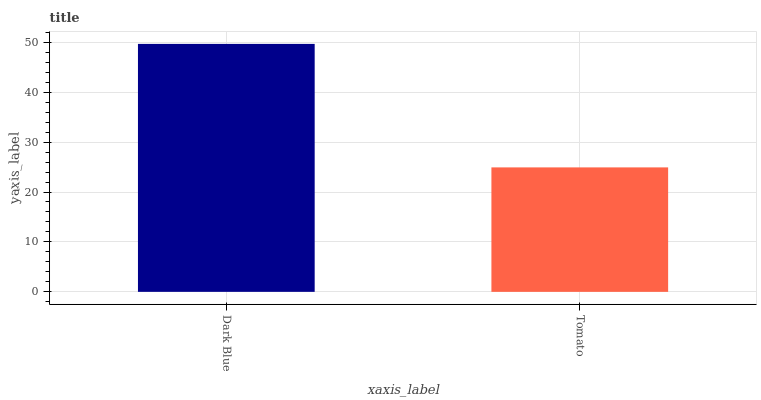Is Tomato the maximum?
Answer yes or no. No. Is Dark Blue greater than Tomato?
Answer yes or no. Yes. Is Tomato less than Dark Blue?
Answer yes or no. Yes. Is Tomato greater than Dark Blue?
Answer yes or no. No. Is Dark Blue less than Tomato?
Answer yes or no. No. Is Dark Blue the high median?
Answer yes or no. Yes. Is Tomato the low median?
Answer yes or no. Yes. Is Tomato the high median?
Answer yes or no. No. Is Dark Blue the low median?
Answer yes or no. No. 